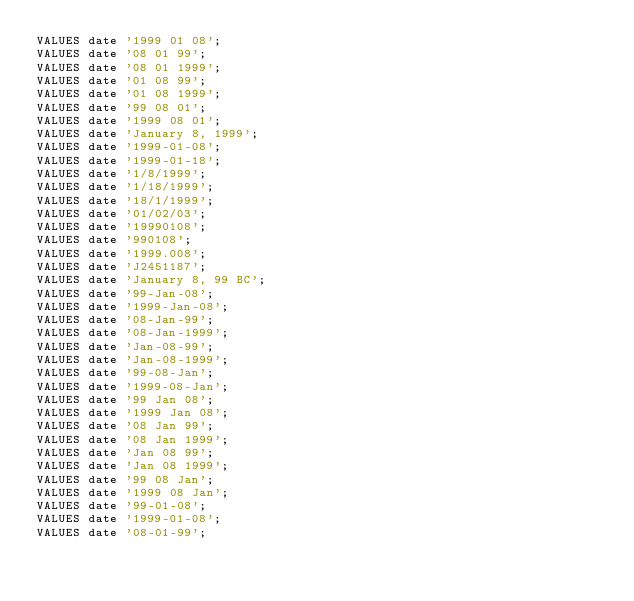<code> <loc_0><loc_0><loc_500><loc_500><_SQL_>VALUES date '1999 01 08';
VALUES date '08 01 99';
VALUES date '08 01 1999';
VALUES date '01 08 99';
VALUES date '01 08 1999';
VALUES date '99 08 01';
VALUES date '1999 08 01';
VALUES date 'January 8, 1999';
VALUES date '1999-01-08';
VALUES date '1999-01-18';
VALUES date '1/8/1999';
VALUES date '1/18/1999';
VALUES date '18/1/1999';
VALUES date '01/02/03';
VALUES date '19990108';
VALUES date '990108';
VALUES date '1999.008';
VALUES date 'J2451187';
VALUES date 'January 8, 99 BC';
VALUES date '99-Jan-08';
VALUES date '1999-Jan-08';
VALUES date '08-Jan-99';
VALUES date '08-Jan-1999';
VALUES date 'Jan-08-99';
VALUES date 'Jan-08-1999';
VALUES date '99-08-Jan';
VALUES date '1999-08-Jan';
VALUES date '99 Jan 08';
VALUES date '1999 Jan 08';
VALUES date '08 Jan 99';
VALUES date '08 Jan 1999';
VALUES date 'Jan 08 99';
VALUES date 'Jan 08 1999';
VALUES date '99 08 Jan';
VALUES date '1999 08 Jan';
VALUES date '99-01-08';
VALUES date '1999-01-08';
VALUES date '08-01-99';</code> 